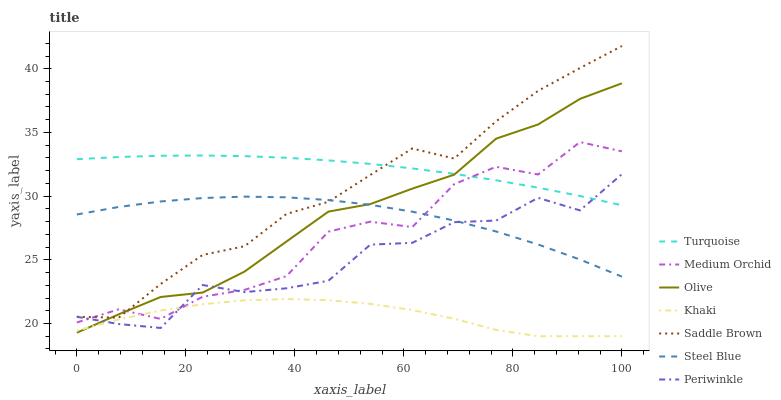Does Khaki have the minimum area under the curve?
Answer yes or no. Yes. Does Turquoise have the maximum area under the curve?
Answer yes or no. Yes. Does Medium Orchid have the minimum area under the curve?
Answer yes or no. No. Does Medium Orchid have the maximum area under the curve?
Answer yes or no. No. Is Turquoise the smoothest?
Answer yes or no. Yes. Is Medium Orchid the roughest?
Answer yes or no. Yes. Is Khaki the smoothest?
Answer yes or no. No. Is Khaki the roughest?
Answer yes or no. No. Does Khaki have the lowest value?
Answer yes or no. Yes. Does Medium Orchid have the lowest value?
Answer yes or no. No. Does Saddle Brown have the highest value?
Answer yes or no. Yes. Does Medium Orchid have the highest value?
Answer yes or no. No. Is Steel Blue less than Turquoise?
Answer yes or no. Yes. Is Turquoise greater than Steel Blue?
Answer yes or no. Yes. Does Steel Blue intersect Olive?
Answer yes or no. Yes. Is Steel Blue less than Olive?
Answer yes or no. No. Is Steel Blue greater than Olive?
Answer yes or no. No. Does Steel Blue intersect Turquoise?
Answer yes or no. No. 